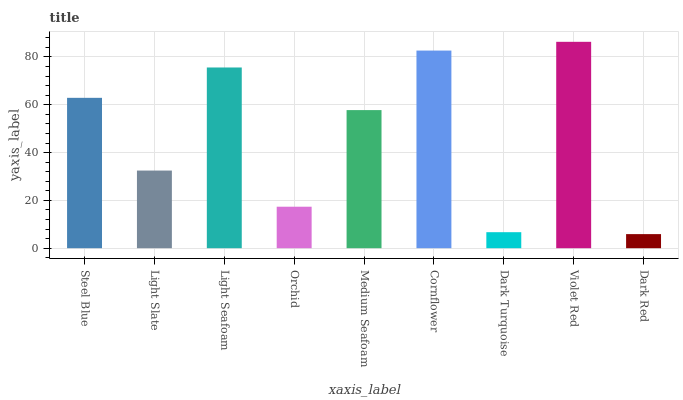Is Dark Red the minimum?
Answer yes or no. Yes. Is Violet Red the maximum?
Answer yes or no. Yes. Is Light Slate the minimum?
Answer yes or no. No. Is Light Slate the maximum?
Answer yes or no. No. Is Steel Blue greater than Light Slate?
Answer yes or no. Yes. Is Light Slate less than Steel Blue?
Answer yes or no. Yes. Is Light Slate greater than Steel Blue?
Answer yes or no. No. Is Steel Blue less than Light Slate?
Answer yes or no. No. Is Medium Seafoam the high median?
Answer yes or no. Yes. Is Medium Seafoam the low median?
Answer yes or no. Yes. Is Cornflower the high median?
Answer yes or no. No. Is Light Slate the low median?
Answer yes or no. No. 